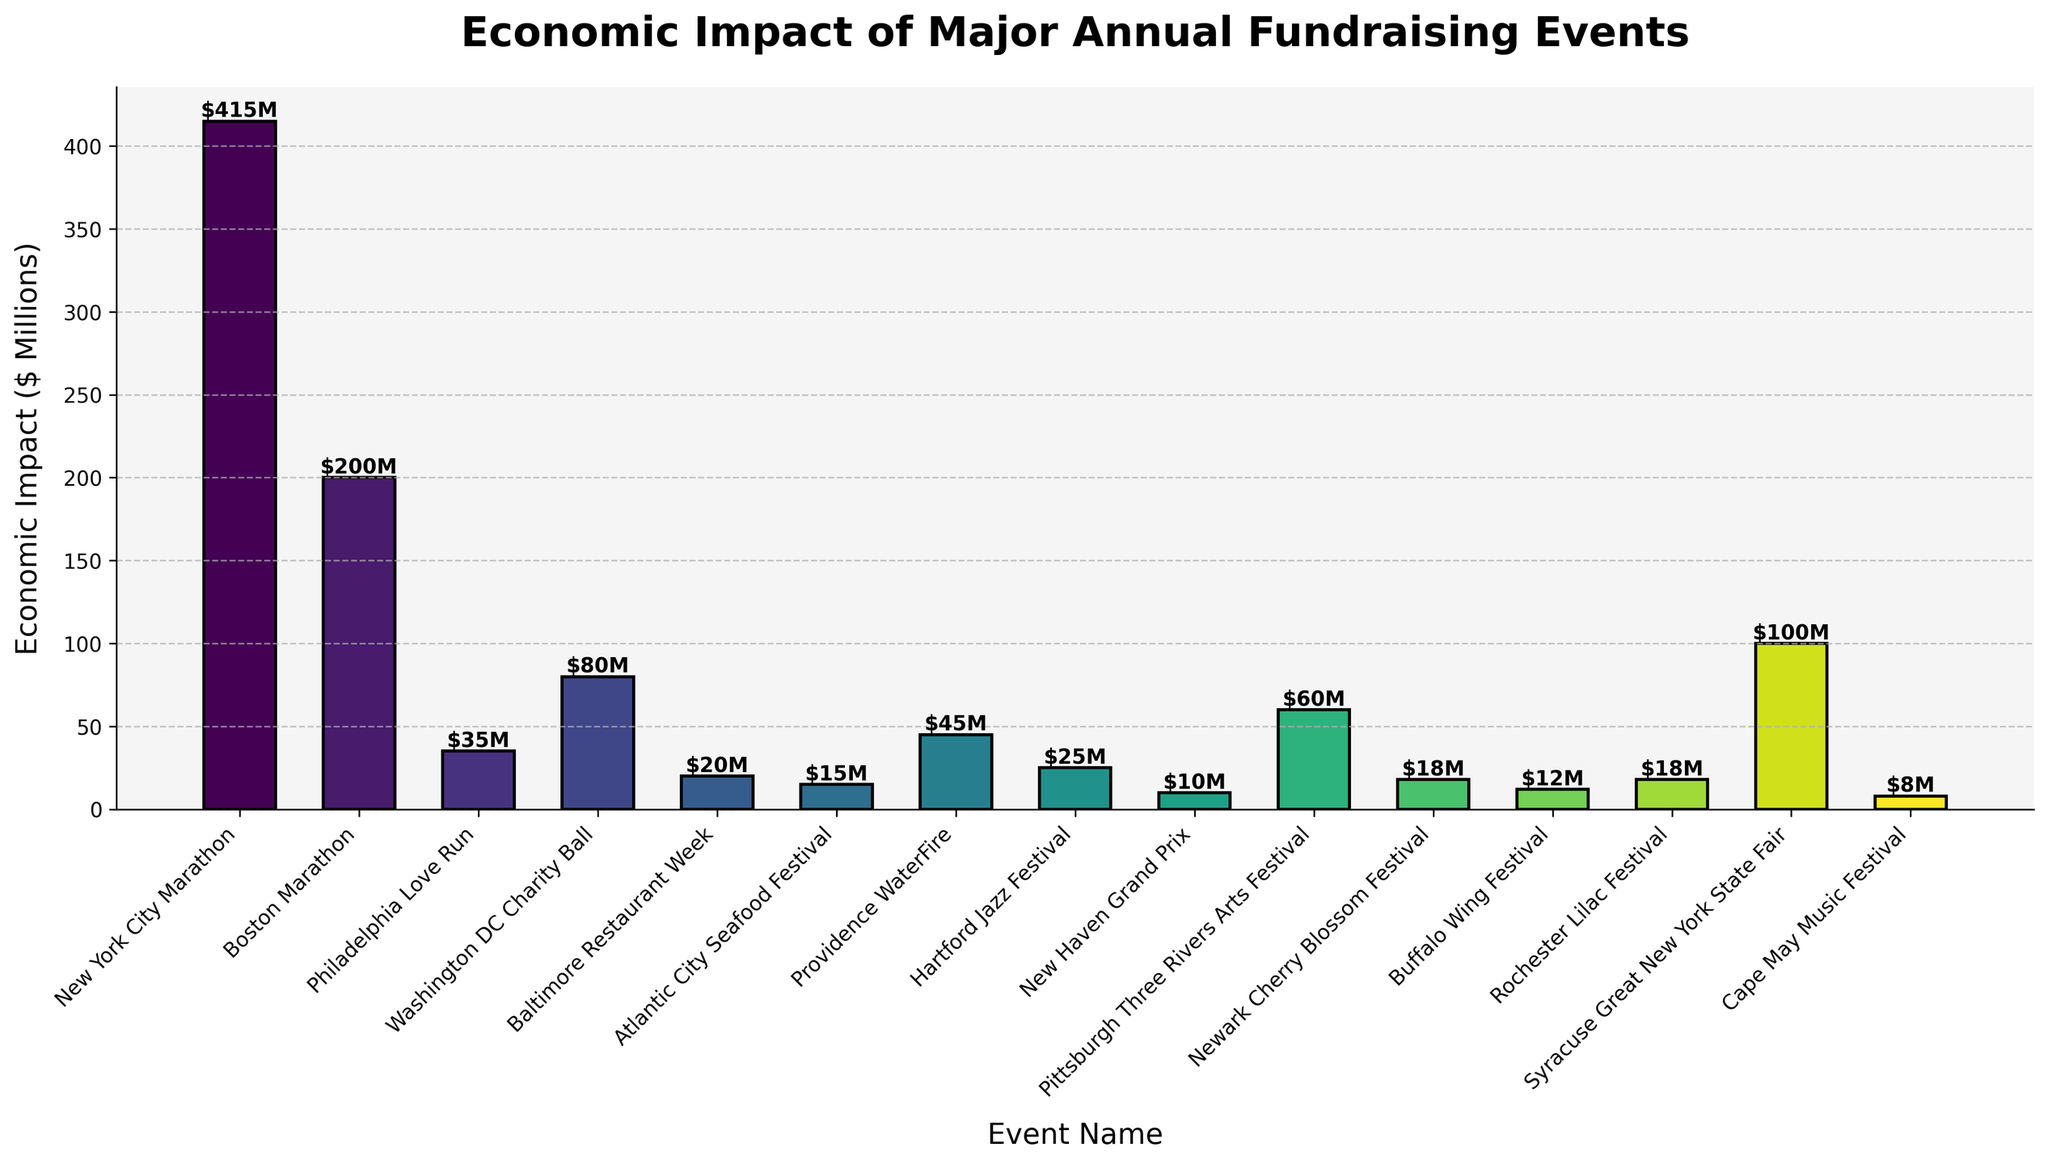What's the event with the highest economic impact? The height of the bar representing New York City Marathon is the tallest, indicating it has the highest economic impact at $415 million.
Answer: New York City Marathon Which event has a higher economic impact, the Boston Marathon or the Syracuse Great New York State Fair? By comparing the height of the bars, Boston Marathon has a higher economic impact at $200 million compared to the Syracuse Great New York State Fair at $100 million.
Answer: Boston Marathon What is the total economic impact of the Philadelphia Love Run, Baltimore Restaurant Week, and Hartford Jazz Festival combined? Adding the economic impacts: 35 (Philadelphia Love Run) + 20 (Baltimore Restaurant Week) + 25 (Hartford Jazz Festival) equals $80 million.
Answer: $80 million Which event has the lowest economic impact? The bar for the Cape May Music Festival is the shortest, indicating the lowest economic impact at $8 million.
Answer: Cape May Music Festival What is the difference in economic impact between the New York City Marathon and the Washington DC Charity Ball? Subtract the economic impacts: 415 (New York City Marathon) - 80 (Washington DC Charity Ball) equals $335 million.
Answer: $335 million What is the average economic impact of the top three events? Sum the economic impacts of the top three events: 415 (New York City Marathon) + 200 (Boston Marathon) + 100 (Syracuse Great New York State Fair) = 715. Divide by 3 for the average: 715 / 3 ~ 238.33 million.
Answer: ~$238.33 million How many events have an economic impact of more than $50 million? By visually inspecting the heights of the bars, 5 events (New York City Marathon, Boston Marathon, Washington DC Charity Ball, Syracuse Great New York State Fair, and Pittsburgh Three Rivers Arts Festival) have an impact greater than $50 million.
Answer: 5 What is the combined economic impact of all events that are held in New Jersey? Considering only two events in New Jersey: Atlantic City Seafood Festival ($15 million) and Cape May Music Festival ($8 million), sum the impacts: 15 + 8 equals $23 million.
Answer: $23 million Which event is located between the Baltimore Restaurant Week and the Hartford Jazz Festival in terms of economic impact? Philadelphia Love Run, with an economic impact of $35 million, is the event located between Baltimore Restaurant Week ($20M) and Hartford Jazz Festival ($25M) in terms of economic impact.
Answer: Philadelphia Love Run What's the economic impact difference between Providence WaterFire and Newark Cherry Blossom Festival? Subtract the economic impacts: 45 (Providence WaterFire) - 18 (Newark Cherry Blossom Festival) equals $27 million.
Answer: $27 million 